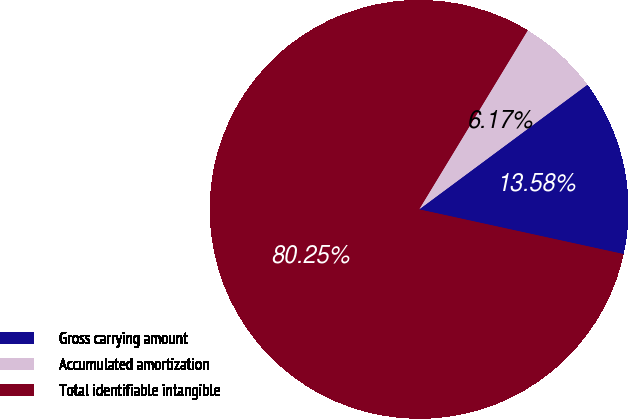<chart> <loc_0><loc_0><loc_500><loc_500><pie_chart><fcel>Gross carrying amount<fcel>Accumulated amortization<fcel>Total identifiable intangible<nl><fcel>13.58%<fcel>6.17%<fcel>80.26%<nl></chart> 